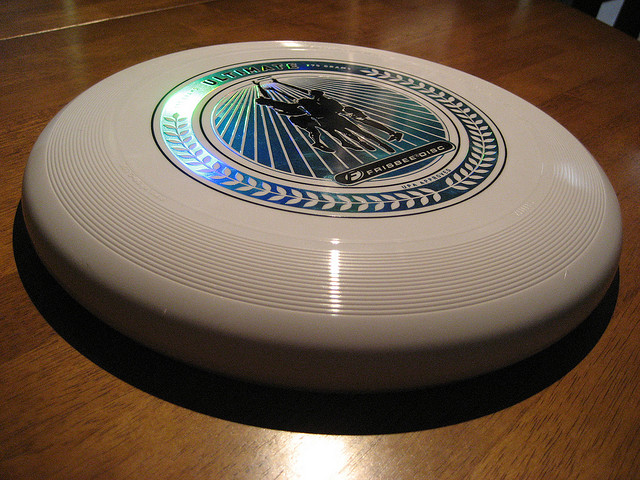Identify the text displayed in this image. ULTIMATE PRUBBEEDISC 